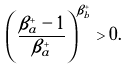<formula> <loc_0><loc_0><loc_500><loc_500>\left ( \frac { \beta ^ { + } _ { a } - 1 } { \beta ^ { + } _ { a } } \right ) ^ { \beta ^ { + } _ { b } } > 0 .</formula> 